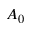Convert formula to latex. <formula><loc_0><loc_0><loc_500><loc_500>A _ { 0 }</formula> 